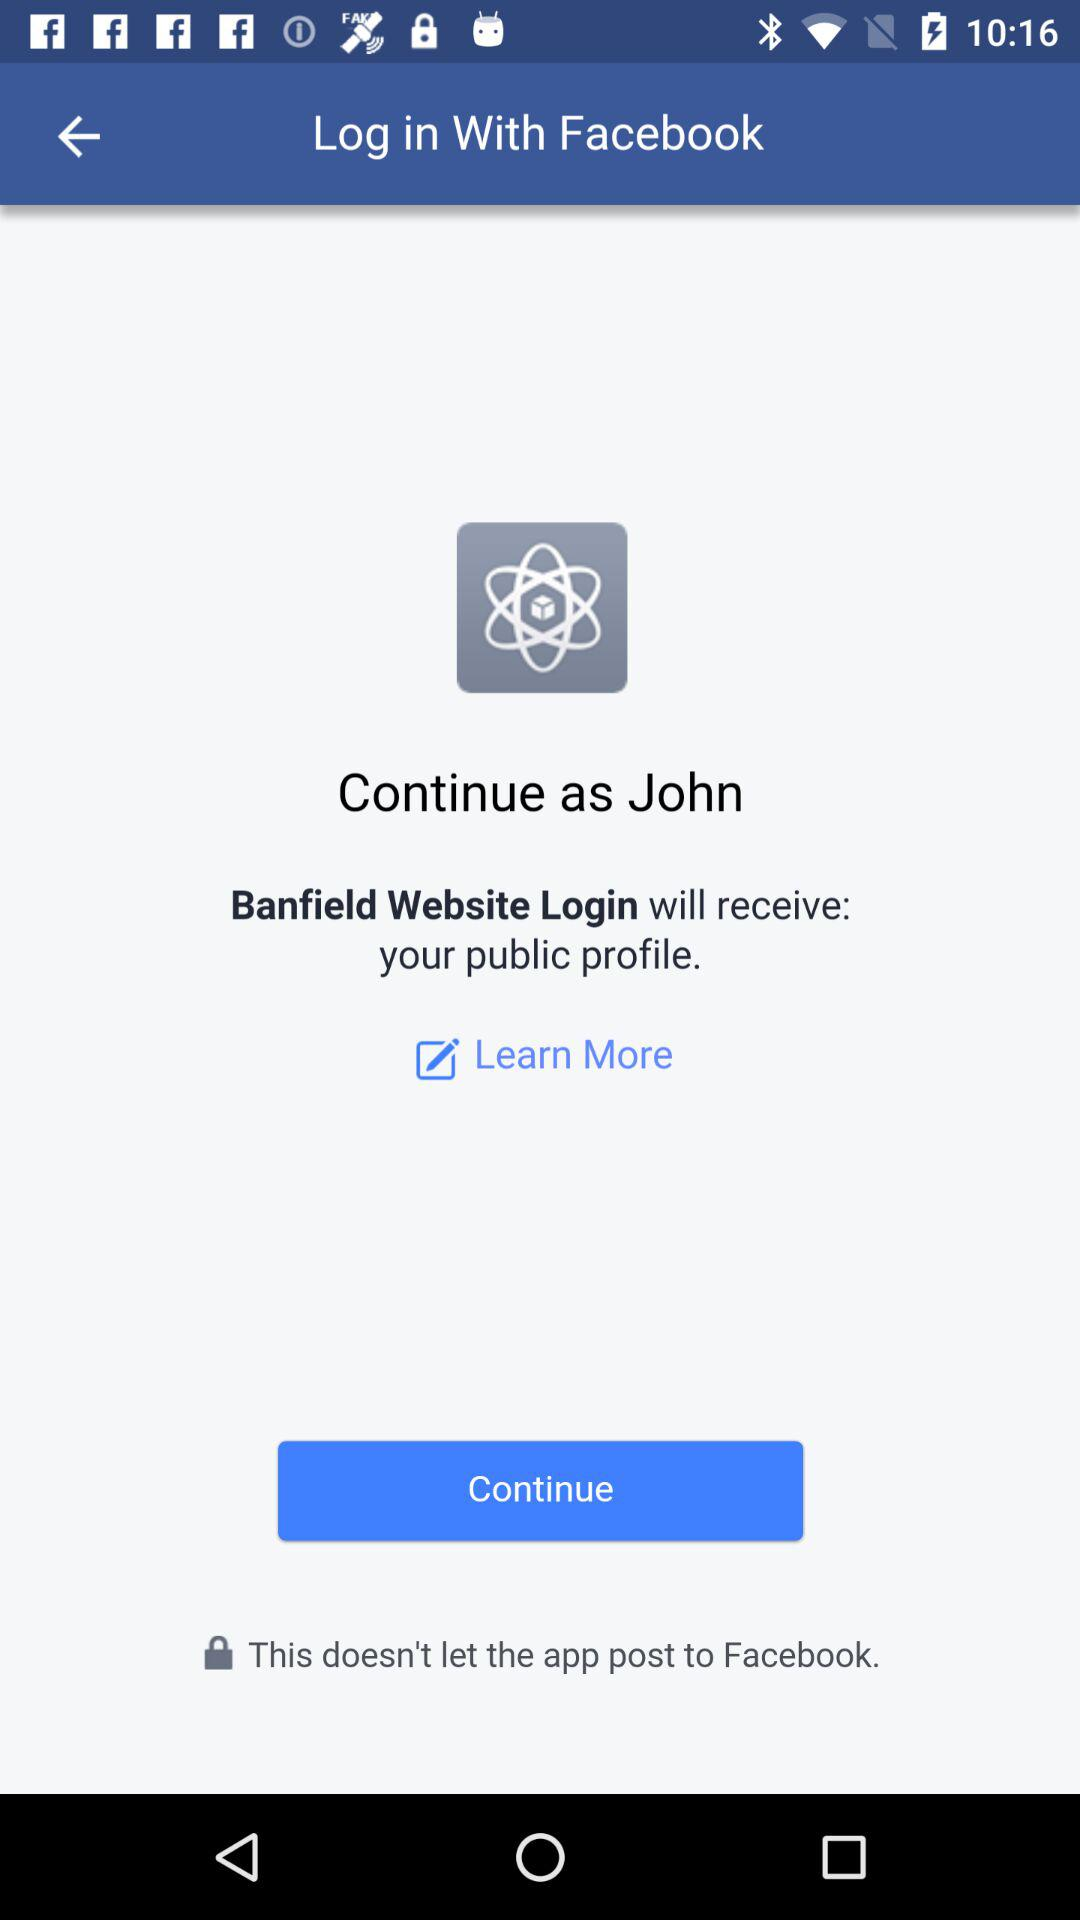What is the name of the user? The name of the user is John. 